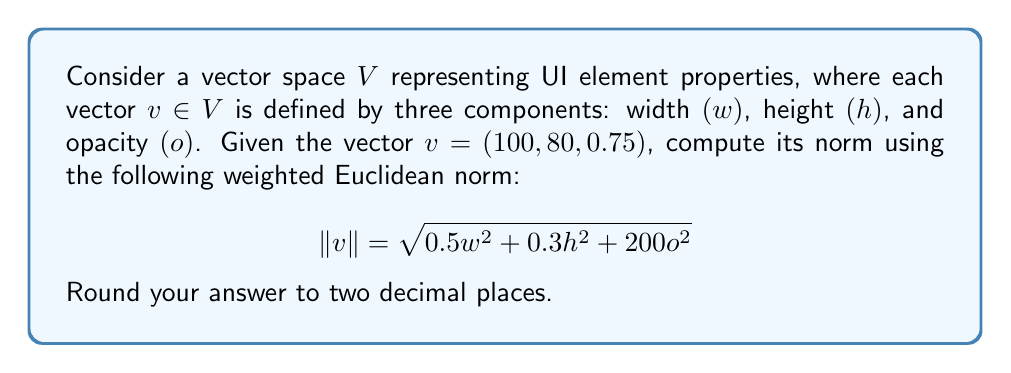Provide a solution to this math problem. To compute the norm of the given vector $v = (100, 80, 0.75)$ using the specified weighted Euclidean norm, we'll follow these steps:

1. Identify the components of the vector:
   $w = 100$ (width)
   $h = 80$ (height)
   $o = 0.75$ (opacity)

2. Substitute these values into the given norm formula:

   $$\|v\| = \sqrt{0.5w^2 + 0.3h^2 + 200o^2}$$

3. Calculate each term inside the square root:
   $0.5w^2 = 0.5 \cdot (100)^2 = 0.5 \cdot 10000 = 5000$
   $0.3h^2 = 0.3 \cdot (80)^2 = 0.3 \cdot 6400 = 1920$
   $200o^2 = 200 \cdot (0.75)^2 = 200 \cdot 0.5625 = 112.5$

4. Sum the terms under the square root:
   $5000 + 1920 + 112.5 = 7032.5$

5. Take the square root of the sum:
   $$\|v\| = \sqrt{7032.5} \approx 83.86$$

6. Round the result to two decimal places: 83.86

This weighted Euclidean norm gives more importance to the width and height components compared to the opacity, which is suitable for UI design where dimensions often have a more significant impact on layout than opacity.
Answer: $\|v\| \approx 83.86$ 